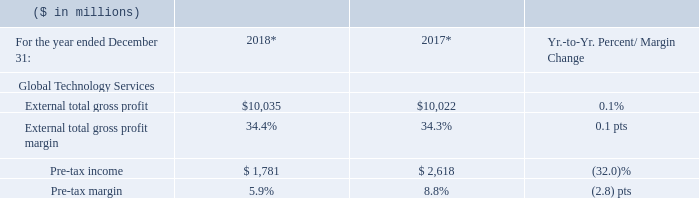* Recast to reflect segment changes.
The 2018 GTS gross profit margin was essentially flat year to year and reflected benefits from productivity initiatives, including automation of delivery processes infused with AI and global workforce optimization.
Pre-tax income performance reflected continued investment to expand go-to-market capabilities and develop new offerings for the hybrid market.
What are the benefits reflected from gross profit margin? The 2018 gts gross profit margin was essentially flat year to year and reflected benefits from productivity initiatives. What does the productivity initiatives include? Automation of delivery processes infused with ai and global workforce optimization. What does the Pre-tax income performance implied?  Pre-tax income performance reflected continued investment to expand go-to-market capabilities and develop new offerings for the hybrid market. What is the average of External total gross profit?
Answer scale should be: million. (10,035+10,022) / 2
Answer: 10028.5. What is the increase/ (decrease) in External total gross profit from 2017 to 2018
Answer scale should be: million. 10,035-10,022
Answer: 13. What is the increase/ (decrease) in Pre-tax income from 2017 to 2018
Answer scale should be: million. 1,781-2,618 
Answer: -837. 